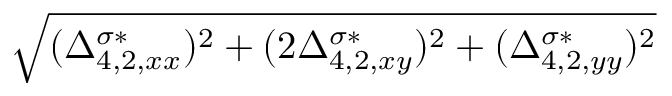<formula> <loc_0><loc_0><loc_500><loc_500>\sqrt { ( \Delta _ { 4 , 2 , x x } ^ { \sigma * } ) ^ { 2 } + ( 2 \Delta _ { 4 , 2 , x y } ^ { \sigma * } ) ^ { 2 } + ( \Delta _ { 4 , 2 , y y } ^ { \sigma * } ) ^ { 2 } }</formula> 